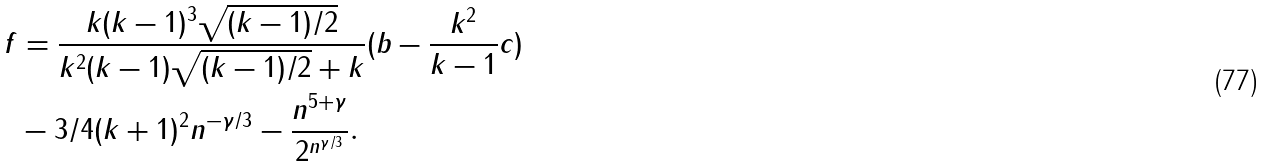Convert formula to latex. <formula><loc_0><loc_0><loc_500><loc_500>f & = \frac { k ( k - 1 ) ^ { 3 } \sqrt { ( k - 1 ) / 2 } } { k ^ { 2 } ( k - 1 ) \sqrt { ( k - 1 ) / 2 } + k } ( b - \frac { k ^ { 2 } } { k - 1 } c ) \\ & - 3 / 4 ( k + 1 ) ^ { 2 } n ^ { - \gamma / 3 } - \frac { n ^ { 5 + \gamma } } { 2 ^ { n ^ { \gamma / 3 } } } .</formula> 